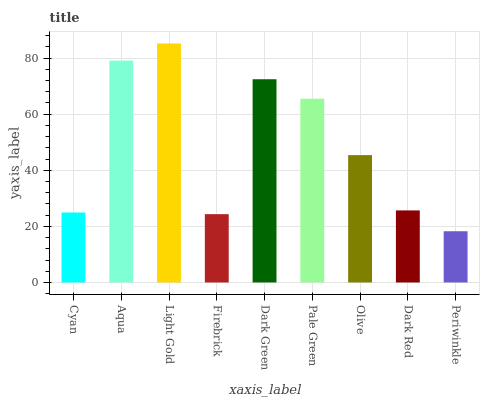Is Periwinkle the minimum?
Answer yes or no. Yes. Is Light Gold the maximum?
Answer yes or no. Yes. Is Aqua the minimum?
Answer yes or no. No. Is Aqua the maximum?
Answer yes or no. No. Is Aqua greater than Cyan?
Answer yes or no. Yes. Is Cyan less than Aqua?
Answer yes or no. Yes. Is Cyan greater than Aqua?
Answer yes or no. No. Is Aqua less than Cyan?
Answer yes or no. No. Is Olive the high median?
Answer yes or no. Yes. Is Olive the low median?
Answer yes or no. Yes. Is Dark Red the high median?
Answer yes or no. No. Is Periwinkle the low median?
Answer yes or no. No. 